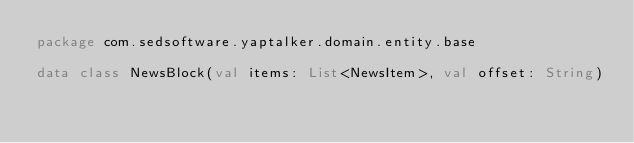Convert code to text. <code><loc_0><loc_0><loc_500><loc_500><_Kotlin_>package com.sedsoftware.yaptalker.domain.entity.base

data class NewsBlock(val items: List<NewsItem>, val offset: String)
</code> 